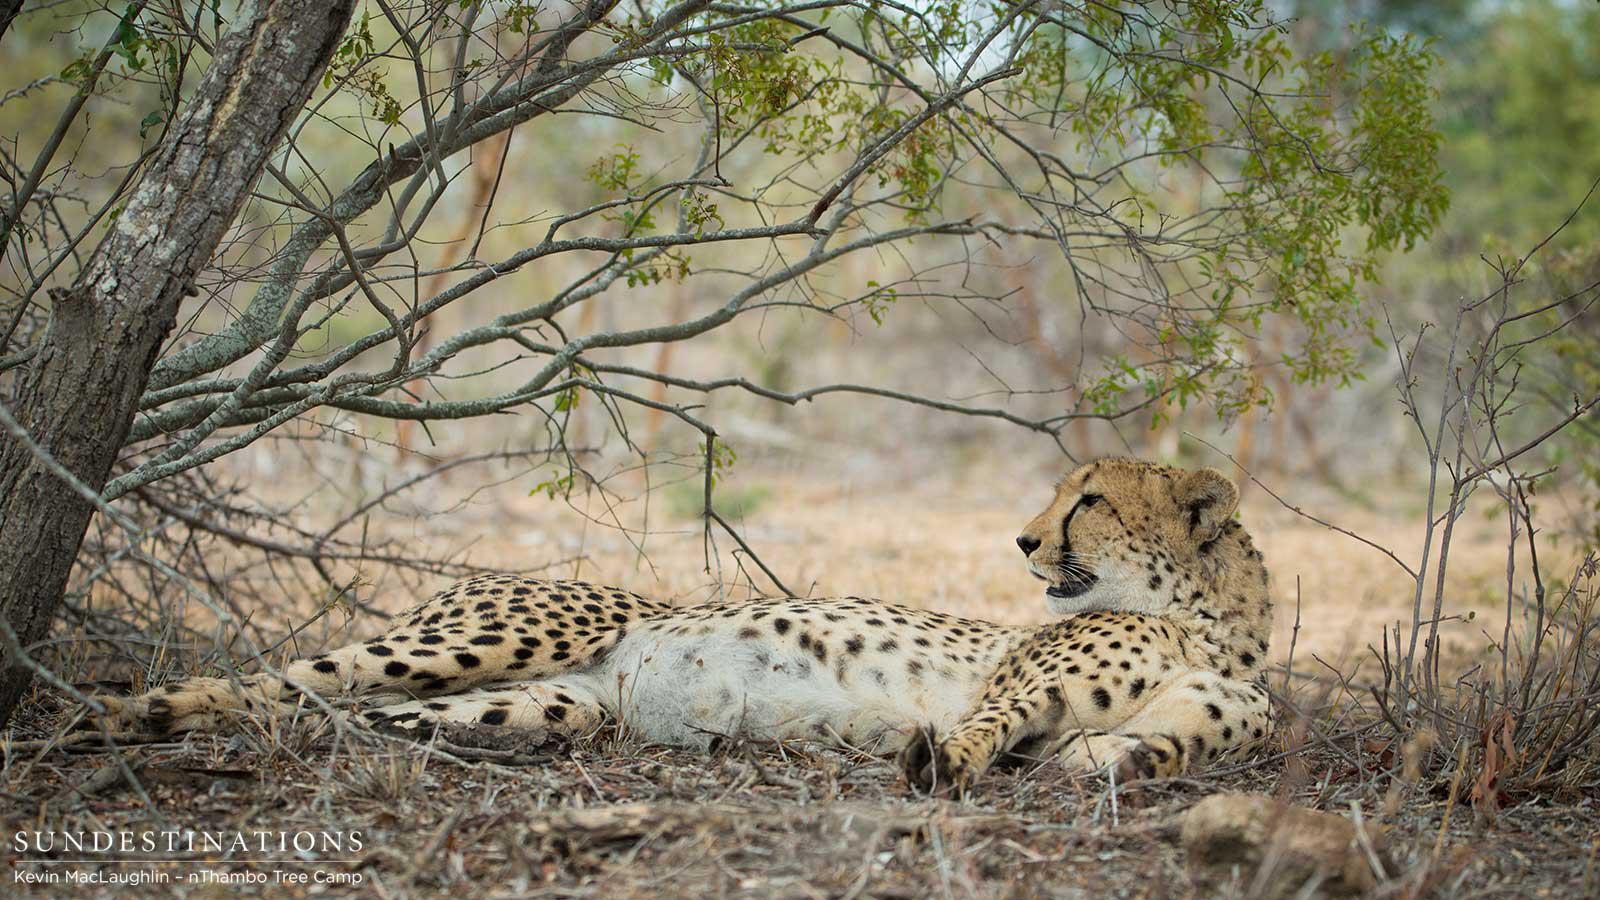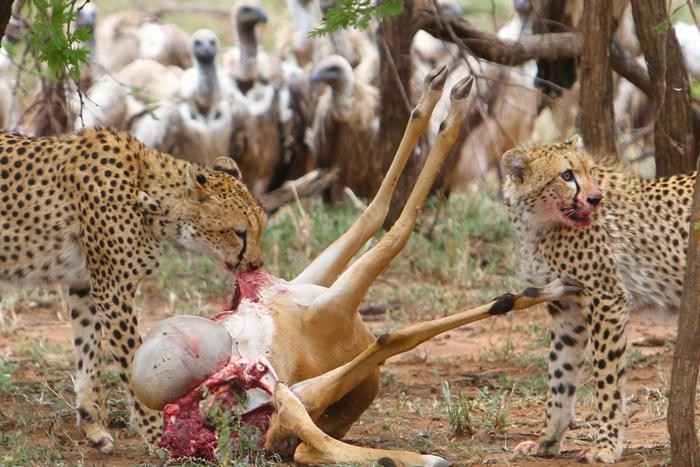The first image is the image on the left, the second image is the image on the right. Given the left and right images, does the statement "There is exactly two cheetahs in the left image." hold true? Answer yes or no. No. 